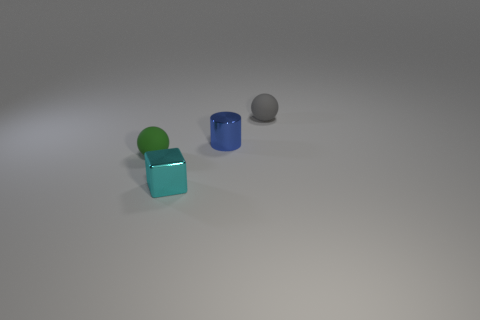Add 2 cyan shiny objects. How many objects exist? 6 Subtract all blocks. How many objects are left? 3 Subtract all gray balls. Subtract all tiny blue matte balls. How many objects are left? 3 Add 4 small cylinders. How many small cylinders are left? 5 Add 1 green matte balls. How many green matte balls exist? 2 Subtract 0 cyan spheres. How many objects are left? 4 